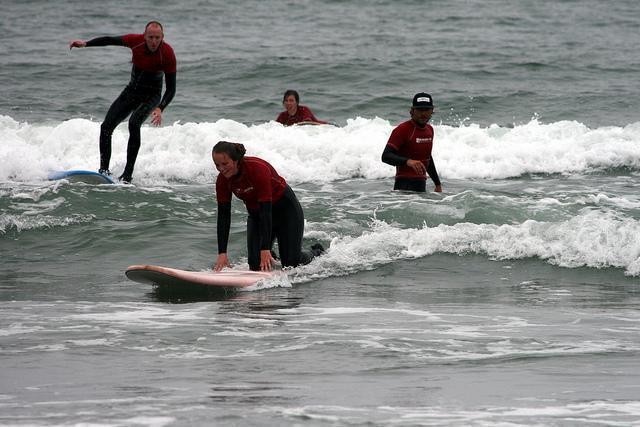What does the girl walking into the water is waiting for what to come from directly behind her so she can stand up on the board from the water waiting for what the only thing that will get her on moving on the board?
Make your selection and explain in format: 'Answer: answer
Rationale: rationale.'
Options: Wave, sun, her hands, sand. Answer: wave.
Rationale: The girl is behind the waves and is waiting for another wave to form. 